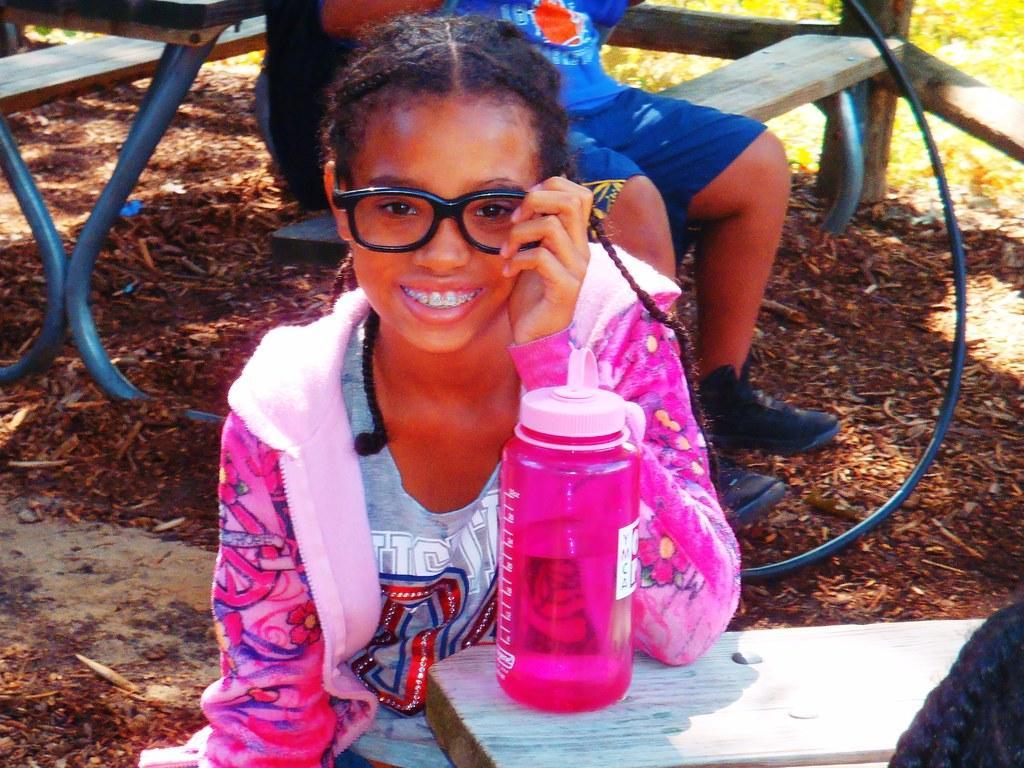Can you describe this image briefly? In this image there is a girl sitting and smiling. At the back there is an other person sitting on the bench. There is a bottle on the table. At the bottom there are leaves. 